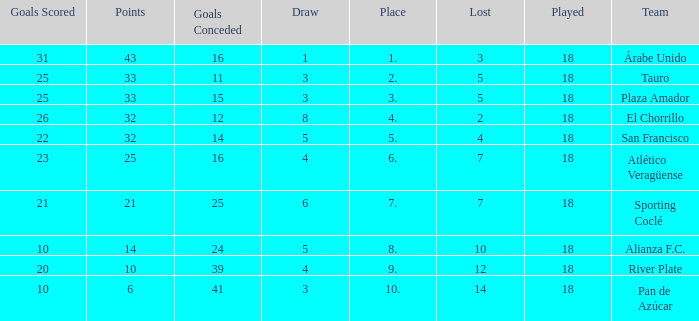How many goals were conceded by teams with 32 points, more than 2 losses and more than 22 goals scored? 0.0. 